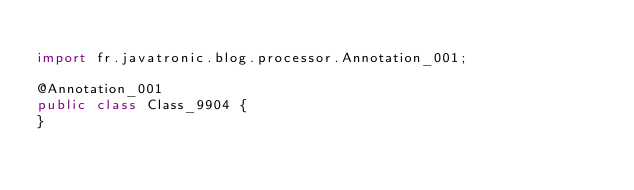<code> <loc_0><loc_0><loc_500><loc_500><_Java_>
import fr.javatronic.blog.processor.Annotation_001;

@Annotation_001
public class Class_9904 {
}
</code> 